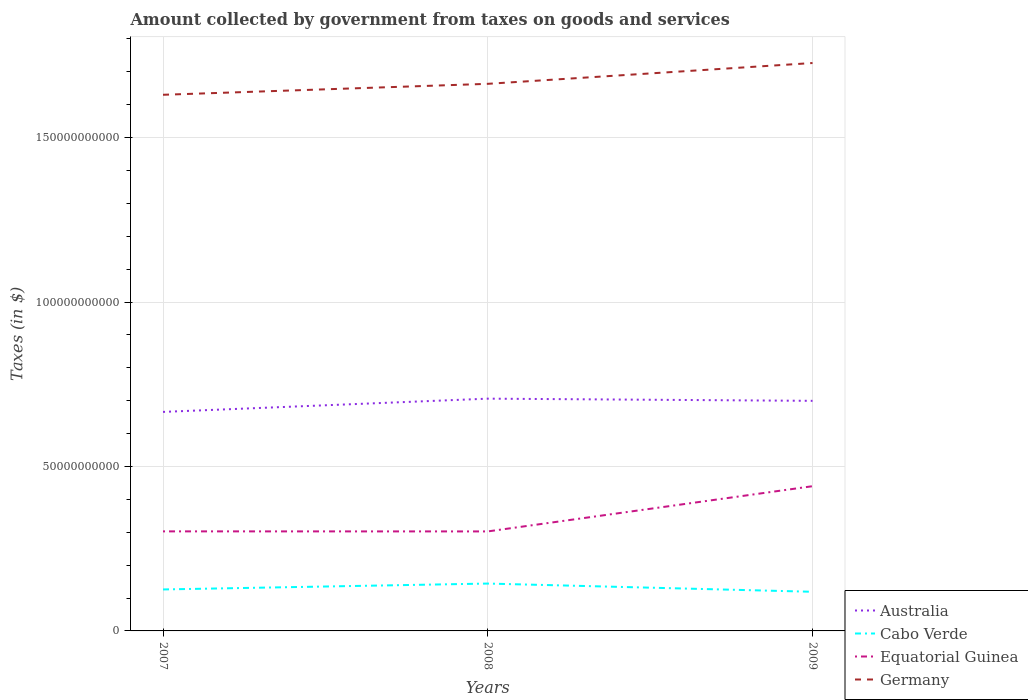How many different coloured lines are there?
Keep it short and to the point. 4. Across all years, what is the maximum amount collected by government from taxes on goods and services in Cabo Verde?
Offer a terse response. 1.19e+1. In which year was the amount collected by government from taxes on goods and services in Equatorial Guinea maximum?
Give a very brief answer. 2008. What is the total amount collected by government from taxes on goods and services in Germany in the graph?
Your response must be concise. -6.33e+09. What is the difference between the highest and the second highest amount collected by government from taxes on goods and services in Equatorial Guinea?
Your answer should be compact. 1.37e+1. How many years are there in the graph?
Your response must be concise. 3. What is the difference between two consecutive major ticks on the Y-axis?
Provide a short and direct response. 5.00e+1. Does the graph contain grids?
Provide a short and direct response. Yes. Where does the legend appear in the graph?
Make the answer very short. Bottom right. How are the legend labels stacked?
Give a very brief answer. Vertical. What is the title of the graph?
Make the answer very short. Amount collected by government from taxes on goods and services. What is the label or title of the Y-axis?
Your answer should be compact. Taxes (in $). What is the Taxes (in $) in Australia in 2007?
Your answer should be very brief. 6.66e+1. What is the Taxes (in $) in Cabo Verde in 2007?
Offer a very short reply. 1.26e+1. What is the Taxes (in $) in Equatorial Guinea in 2007?
Your answer should be very brief. 3.03e+1. What is the Taxes (in $) of Germany in 2007?
Give a very brief answer. 1.63e+11. What is the Taxes (in $) in Australia in 2008?
Offer a very short reply. 7.06e+1. What is the Taxes (in $) of Cabo Verde in 2008?
Offer a very short reply. 1.44e+1. What is the Taxes (in $) in Equatorial Guinea in 2008?
Your answer should be compact. 3.03e+1. What is the Taxes (in $) of Germany in 2008?
Your response must be concise. 1.66e+11. What is the Taxes (in $) in Australia in 2009?
Make the answer very short. 7.00e+1. What is the Taxes (in $) in Cabo Verde in 2009?
Offer a very short reply. 1.19e+1. What is the Taxes (in $) of Equatorial Guinea in 2009?
Give a very brief answer. 4.40e+1. What is the Taxes (in $) of Germany in 2009?
Keep it short and to the point. 1.73e+11. Across all years, what is the maximum Taxes (in $) in Australia?
Your answer should be compact. 7.06e+1. Across all years, what is the maximum Taxes (in $) of Cabo Verde?
Offer a terse response. 1.44e+1. Across all years, what is the maximum Taxes (in $) in Equatorial Guinea?
Provide a succinct answer. 4.40e+1. Across all years, what is the maximum Taxes (in $) of Germany?
Provide a short and direct response. 1.73e+11. Across all years, what is the minimum Taxes (in $) of Australia?
Give a very brief answer. 6.66e+1. Across all years, what is the minimum Taxes (in $) of Cabo Verde?
Ensure brevity in your answer.  1.19e+1. Across all years, what is the minimum Taxes (in $) in Equatorial Guinea?
Your answer should be very brief. 3.03e+1. Across all years, what is the minimum Taxes (in $) of Germany?
Make the answer very short. 1.63e+11. What is the total Taxes (in $) of Australia in the graph?
Provide a succinct answer. 2.07e+11. What is the total Taxes (in $) in Cabo Verde in the graph?
Offer a very short reply. 3.89e+1. What is the total Taxes (in $) of Equatorial Guinea in the graph?
Offer a terse response. 1.05e+11. What is the total Taxes (in $) in Germany in the graph?
Give a very brief answer. 5.02e+11. What is the difference between the Taxes (in $) in Australia in 2007 and that in 2008?
Your answer should be compact. -4.03e+09. What is the difference between the Taxes (in $) of Cabo Verde in 2007 and that in 2008?
Ensure brevity in your answer.  -1.79e+09. What is the difference between the Taxes (in $) of Equatorial Guinea in 2007 and that in 2008?
Offer a very short reply. 1.60e+07. What is the difference between the Taxes (in $) of Germany in 2007 and that in 2008?
Your response must be concise. -3.33e+09. What is the difference between the Taxes (in $) of Australia in 2007 and that in 2009?
Offer a terse response. -3.36e+09. What is the difference between the Taxes (in $) in Cabo Verde in 2007 and that in 2009?
Your answer should be compact. 7.08e+08. What is the difference between the Taxes (in $) in Equatorial Guinea in 2007 and that in 2009?
Ensure brevity in your answer.  -1.37e+1. What is the difference between the Taxes (in $) in Germany in 2007 and that in 2009?
Your response must be concise. -9.66e+09. What is the difference between the Taxes (in $) of Australia in 2008 and that in 2009?
Provide a short and direct response. 6.66e+08. What is the difference between the Taxes (in $) in Cabo Verde in 2008 and that in 2009?
Ensure brevity in your answer.  2.50e+09. What is the difference between the Taxes (in $) of Equatorial Guinea in 2008 and that in 2009?
Offer a terse response. -1.37e+1. What is the difference between the Taxes (in $) in Germany in 2008 and that in 2009?
Your response must be concise. -6.33e+09. What is the difference between the Taxes (in $) of Australia in 2007 and the Taxes (in $) of Cabo Verde in 2008?
Provide a succinct answer. 5.22e+1. What is the difference between the Taxes (in $) of Australia in 2007 and the Taxes (in $) of Equatorial Guinea in 2008?
Ensure brevity in your answer.  3.63e+1. What is the difference between the Taxes (in $) in Australia in 2007 and the Taxes (in $) in Germany in 2008?
Your answer should be compact. -9.97e+1. What is the difference between the Taxes (in $) in Cabo Verde in 2007 and the Taxes (in $) in Equatorial Guinea in 2008?
Offer a very short reply. -1.76e+1. What is the difference between the Taxes (in $) of Cabo Verde in 2007 and the Taxes (in $) of Germany in 2008?
Offer a very short reply. -1.54e+11. What is the difference between the Taxes (in $) of Equatorial Guinea in 2007 and the Taxes (in $) of Germany in 2008?
Your answer should be compact. -1.36e+11. What is the difference between the Taxes (in $) in Australia in 2007 and the Taxes (in $) in Cabo Verde in 2009?
Make the answer very short. 5.47e+1. What is the difference between the Taxes (in $) in Australia in 2007 and the Taxes (in $) in Equatorial Guinea in 2009?
Your answer should be very brief. 2.26e+1. What is the difference between the Taxes (in $) in Australia in 2007 and the Taxes (in $) in Germany in 2009?
Ensure brevity in your answer.  -1.06e+11. What is the difference between the Taxes (in $) in Cabo Verde in 2007 and the Taxes (in $) in Equatorial Guinea in 2009?
Your answer should be very brief. -3.14e+1. What is the difference between the Taxes (in $) of Cabo Verde in 2007 and the Taxes (in $) of Germany in 2009?
Provide a short and direct response. -1.60e+11. What is the difference between the Taxes (in $) of Equatorial Guinea in 2007 and the Taxes (in $) of Germany in 2009?
Provide a succinct answer. -1.42e+11. What is the difference between the Taxes (in $) in Australia in 2008 and the Taxes (in $) in Cabo Verde in 2009?
Offer a very short reply. 5.87e+1. What is the difference between the Taxes (in $) of Australia in 2008 and the Taxes (in $) of Equatorial Guinea in 2009?
Your answer should be compact. 2.66e+1. What is the difference between the Taxes (in $) in Australia in 2008 and the Taxes (in $) in Germany in 2009?
Make the answer very short. -1.02e+11. What is the difference between the Taxes (in $) in Cabo Verde in 2008 and the Taxes (in $) in Equatorial Guinea in 2009?
Make the answer very short. -2.96e+1. What is the difference between the Taxes (in $) of Cabo Verde in 2008 and the Taxes (in $) of Germany in 2009?
Your response must be concise. -1.58e+11. What is the difference between the Taxes (in $) of Equatorial Guinea in 2008 and the Taxes (in $) of Germany in 2009?
Provide a succinct answer. -1.42e+11. What is the average Taxes (in $) in Australia per year?
Ensure brevity in your answer.  6.91e+1. What is the average Taxes (in $) in Cabo Verde per year?
Offer a terse response. 1.30e+1. What is the average Taxes (in $) in Equatorial Guinea per year?
Keep it short and to the point. 3.48e+1. What is the average Taxes (in $) in Germany per year?
Keep it short and to the point. 1.67e+11. In the year 2007, what is the difference between the Taxes (in $) of Australia and Taxes (in $) of Cabo Verde?
Your response must be concise. 5.40e+1. In the year 2007, what is the difference between the Taxes (in $) of Australia and Taxes (in $) of Equatorial Guinea?
Offer a terse response. 3.63e+1. In the year 2007, what is the difference between the Taxes (in $) in Australia and Taxes (in $) in Germany?
Keep it short and to the point. -9.64e+1. In the year 2007, what is the difference between the Taxes (in $) in Cabo Verde and Taxes (in $) in Equatorial Guinea?
Provide a succinct answer. -1.77e+1. In the year 2007, what is the difference between the Taxes (in $) in Cabo Verde and Taxes (in $) in Germany?
Give a very brief answer. -1.50e+11. In the year 2007, what is the difference between the Taxes (in $) of Equatorial Guinea and Taxes (in $) of Germany?
Give a very brief answer. -1.33e+11. In the year 2008, what is the difference between the Taxes (in $) in Australia and Taxes (in $) in Cabo Verde?
Ensure brevity in your answer.  5.62e+1. In the year 2008, what is the difference between the Taxes (in $) in Australia and Taxes (in $) in Equatorial Guinea?
Offer a terse response. 4.04e+1. In the year 2008, what is the difference between the Taxes (in $) of Australia and Taxes (in $) of Germany?
Ensure brevity in your answer.  -9.57e+1. In the year 2008, what is the difference between the Taxes (in $) in Cabo Verde and Taxes (in $) in Equatorial Guinea?
Keep it short and to the point. -1.59e+1. In the year 2008, what is the difference between the Taxes (in $) of Cabo Verde and Taxes (in $) of Germany?
Give a very brief answer. -1.52e+11. In the year 2008, what is the difference between the Taxes (in $) of Equatorial Guinea and Taxes (in $) of Germany?
Ensure brevity in your answer.  -1.36e+11. In the year 2009, what is the difference between the Taxes (in $) of Australia and Taxes (in $) of Cabo Verde?
Provide a succinct answer. 5.81e+1. In the year 2009, what is the difference between the Taxes (in $) in Australia and Taxes (in $) in Equatorial Guinea?
Provide a short and direct response. 2.60e+1. In the year 2009, what is the difference between the Taxes (in $) of Australia and Taxes (in $) of Germany?
Offer a very short reply. -1.03e+11. In the year 2009, what is the difference between the Taxes (in $) in Cabo Verde and Taxes (in $) in Equatorial Guinea?
Your response must be concise. -3.21e+1. In the year 2009, what is the difference between the Taxes (in $) in Cabo Verde and Taxes (in $) in Germany?
Provide a succinct answer. -1.61e+11. In the year 2009, what is the difference between the Taxes (in $) in Equatorial Guinea and Taxes (in $) in Germany?
Your answer should be compact. -1.29e+11. What is the ratio of the Taxes (in $) in Australia in 2007 to that in 2008?
Make the answer very short. 0.94. What is the ratio of the Taxes (in $) in Cabo Verde in 2007 to that in 2008?
Keep it short and to the point. 0.88. What is the ratio of the Taxes (in $) in Germany in 2007 to that in 2008?
Make the answer very short. 0.98. What is the ratio of the Taxes (in $) in Australia in 2007 to that in 2009?
Your answer should be very brief. 0.95. What is the ratio of the Taxes (in $) of Cabo Verde in 2007 to that in 2009?
Provide a succinct answer. 1.06. What is the ratio of the Taxes (in $) in Equatorial Guinea in 2007 to that in 2009?
Keep it short and to the point. 0.69. What is the ratio of the Taxes (in $) in Germany in 2007 to that in 2009?
Ensure brevity in your answer.  0.94. What is the ratio of the Taxes (in $) of Australia in 2008 to that in 2009?
Keep it short and to the point. 1.01. What is the ratio of the Taxes (in $) of Cabo Verde in 2008 to that in 2009?
Make the answer very short. 1.21. What is the ratio of the Taxes (in $) in Equatorial Guinea in 2008 to that in 2009?
Make the answer very short. 0.69. What is the ratio of the Taxes (in $) in Germany in 2008 to that in 2009?
Your answer should be very brief. 0.96. What is the difference between the highest and the second highest Taxes (in $) in Australia?
Give a very brief answer. 6.66e+08. What is the difference between the highest and the second highest Taxes (in $) of Cabo Verde?
Ensure brevity in your answer.  1.79e+09. What is the difference between the highest and the second highest Taxes (in $) of Equatorial Guinea?
Your answer should be compact. 1.37e+1. What is the difference between the highest and the second highest Taxes (in $) of Germany?
Provide a short and direct response. 6.33e+09. What is the difference between the highest and the lowest Taxes (in $) of Australia?
Give a very brief answer. 4.03e+09. What is the difference between the highest and the lowest Taxes (in $) in Cabo Verde?
Your answer should be compact. 2.50e+09. What is the difference between the highest and the lowest Taxes (in $) in Equatorial Guinea?
Offer a terse response. 1.37e+1. What is the difference between the highest and the lowest Taxes (in $) in Germany?
Provide a succinct answer. 9.66e+09. 